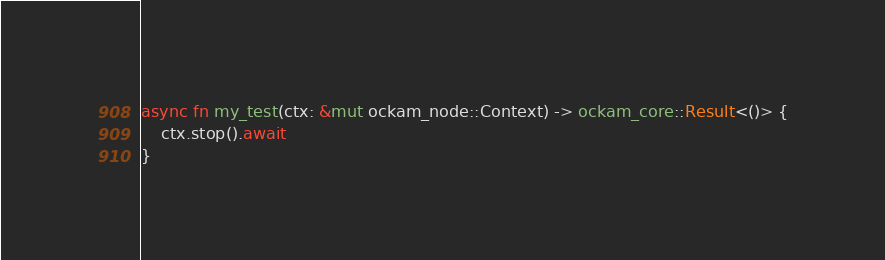Convert code to text. <code><loc_0><loc_0><loc_500><loc_500><_Rust_>async fn my_test(ctx: &mut ockam_node::Context) -> ockam_core::Result<()> {
    ctx.stop().await
}
</code> 